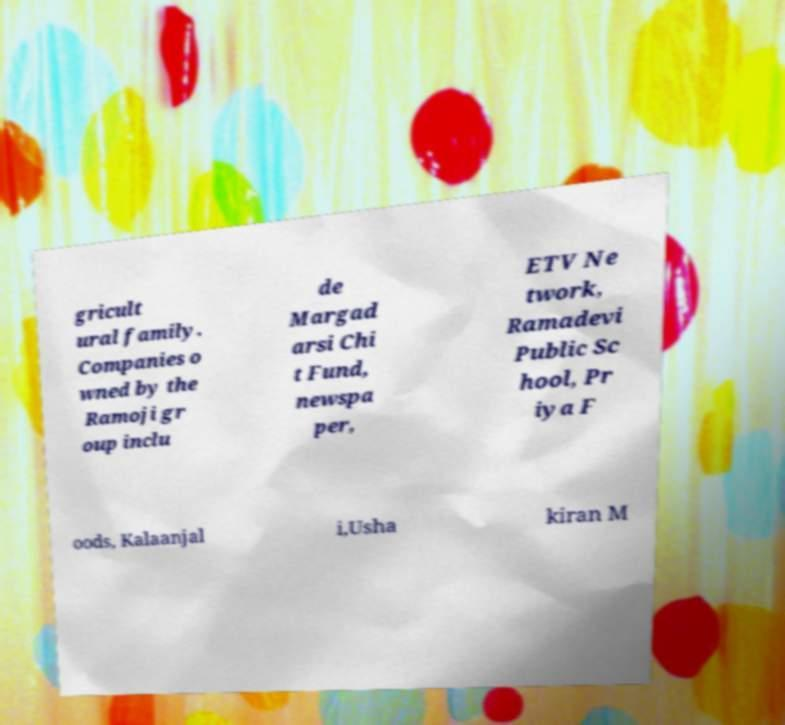For documentation purposes, I need the text within this image transcribed. Could you provide that? gricult ural family. Companies o wned by the Ramoji gr oup inclu de Margad arsi Chi t Fund, newspa per, ETV Ne twork, Ramadevi Public Sc hool, Pr iya F oods, Kalaanjal i,Usha kiran M 